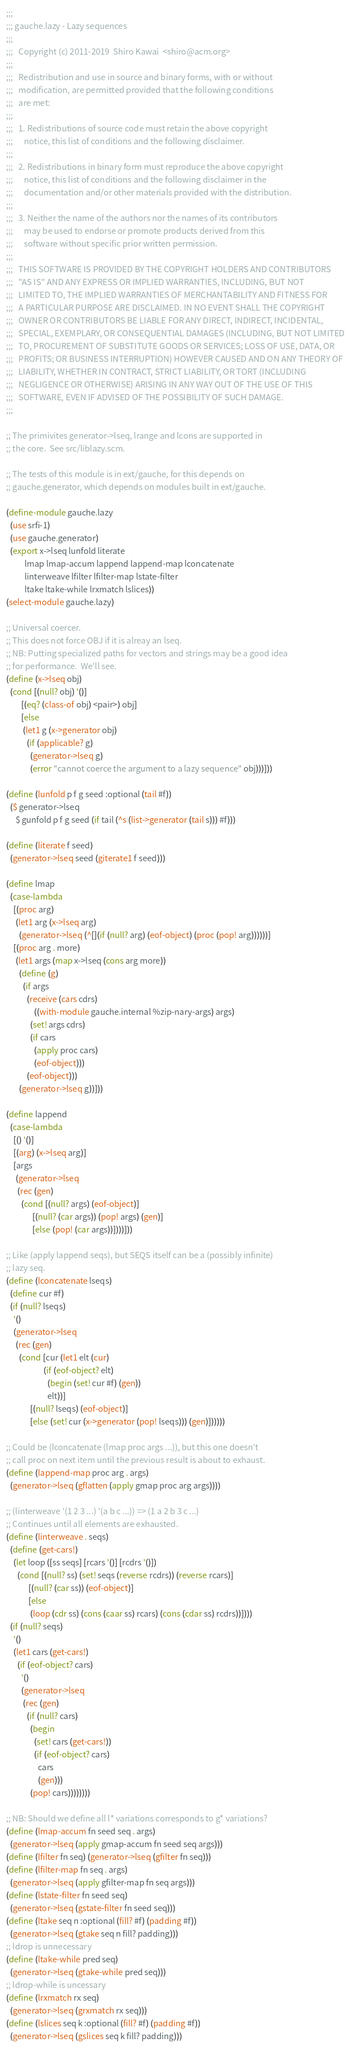<code> <loc_0><loc_0><loc_500><loc_500><_Scheme_>;;;
;;; gauche.lazy - Lazy sequences
;;;
;;;   Copyright (c) 2011-2019  Shiro Kawai  <shiro@acm.org>
;;;
;;;   Redistribution and use in source and binary forms, with or without
;;;   modification, are permitted provided that the following conditions
;;;   are met:
;;;
;;;   1. Redistributions of source code must retain the above copyright
;;;      notice, this list of conditions and the following disclaimer.
;;;
;;;   2. Redistributions in binary form must reproduce the above copyright
;;;      notice, this list of conditions and the following disclaimer in the
;;;      documentation and/or other materials provided with the distribution.
;;;
;;;   3. Neither the name of the authors nor the names of its contributors
;;;      may be used to endorse or promote products derived from this
;;;      software without specific prior written permission.
;;;
;;;   THIS SOFTWARE IS PROVIDED BY THE COPYRIGHT HOLDERS AND CONTRIBUTORS
;;;   "AS IS" AND ANY EXPRESS OR IMPLIED WARRANTIES, INCLUDING, BUT NOT
;;;   LIMITED TO, THE IMPLIED WARRANTIES OF MERCHANTABILITY AND FITNESS FOR
;;;   A PARTICULAR PURPOSE ARE DISCLAIMED. IN NO EVENT SHALL THE COPYRIGHT
;;;   OWNER OR CONTRIBUTORS BE LIABLE FOR ANY DIRECT, INDIRECT, INCIDENTAL,
;;;   SPECIAL, EXEMPLARY, OR CONSEQUENTIAL DAMAGES (INCLUDING, BUT NOT LIMITED
;;;   TO, PROCUREMENT OF SUBSTITUTE GOODS OR SERVICES; LOSS OF USE, DATA, OR
;;;   PROFITS; OR BUSINESS INTERRUPTION) HOWEVER CAUSED AND ON ANY THEORY OF
;;;   LIABILITY, WHETHER IN CONTRACT, STRICT LIABILITY, OR TORT (INCLUDING
;;;   NEGLIGENCE OR OTHERWISE) ARISING IN ANY WAY OUT OF THE USE OF THIS
;;;   SOFTWARE, EVEN IF ADVISED OF THE POSSIBILITY OF SUCH DAMAGE.
;;;

;; The primivites generator->lseq, lrange and lcons are supported in
;; the core.  See src/liblazy.scm.

;; The tests of this module is in ext/gauche, for this depends on
;; gauche.generator, which depends on modules built in ext/gauche.

(define-module gauche.lazy
  (use srfi-1)
  (use gauche.generator)
  (export x->lseq lunfold literate
          lmap lmap-accum lappend lappend-map lconcatenate
          linterweave lfilter lfilter-map lstate-filter
          ltake ltake-while lrxmatch lslices))
(select-module gauche.lazy)

;; Universal coercer.
;; This does not force OBJ if it is alreay an lseq.
;; NB: Putting specialized paths for vectors and strings may be a good idea
;; for performance.  We'll see.
(define (x->lseq obj)
  (cond [(null? obj) '()]
        [(eq? (class-of obj) <pair>) obj]
        [else
         (let1 g (x->generator obj)
           (if (applicable? g)
             (generator->lseq g)
             (error "cannot coerce the argument to a lazy sequence" obj)))]))

(define (lunfold p f g seed :optional (tail #f))
  ($ generator->lseq
     $ gunfold p f g seed (if tail (^s (list->generator (tail s))) #f)))

(define (literate f seed)
  (generator->lseq seed (giterate1 f seed)))

(define lmap
  (case-lambda
    [(proc arg)
     (let1 arg (x->lseq arg)
       (generator->lseq (^[](if (null? arg) (eof-object) (proc (pop! arg))))))]
    [(proc arg . more)
     (let1 args (map x->lseq (cons arg more))
       (define (g)
         (if args
           (receive (cars cdrs)
               ((with-module gauche.internal %zip-nary-args) args)
             (set! args cdrs)
             (if cars
               (apply proc cars)
               (eof-object)))
           (eof-object)))
       (generator->lseq g))]))

(define lappend
  (case-lambda
    [() '()]
    [(arg) (x->lseq arg)]
    [args
     (generator->lseq
      (rec (gen)
        (cond [(null? args) (eof-object)]
              [(null? (car args)) (pop! args) (gen)]
              [else (pop! (car args))])))]))

;; Like (apply lappend seqs), but SEQS itself can be a (possibly infinite)
;; lazy seq.
(define (lconcatenate lseqs)
  (define cur #f)
  (if (null? lseqs)
    '()
    (generator->lseq
     (rec (gen)
       (cond [cur (let1 elt (cur)
                    (if (eof-object? elt)
                      (begin (set! cur #f) (gen))
                      elt))]
             [(null? lseqs) (eof-object)]
             [else (set! cur (x->generator (pop! lseqs))) (gen)])))))

;; Could be (lconcatenate (lmap proc args ...)), but this one doesn't
;; call proc on next item until the previous result is about to exhaust.
(define (lappend-map proc arg . args)
  (generator->lseq (gflatten (apply gmap proc arg args))))

;; (linterweave '(1 2 3 ...) '(a b c ...)) => (1 a 2 b 3 c ...)
;; Continues until all elements are exhausted.
(define (linterweave . seqs)
  (define (get-cars!)
    (let loop ([ss seqs] [rcars '()] [rcdrs '()])
      (cond [(null? ss) (set! seqs (reverse rcdrs)) (reverse rcars)]
            [(null? (car ss)) (eof-object)]
            [else
             (loop (cdr ss) (cons (caar ss) rcars) (cons (cdar ss) rcdrs))])))
  (if (null? seqs)
    '()
    (let1 cars (get-cars!)
      (if (eof-object? cars)
        '()
        (generator->lseq
         (rec (gen)
           (if (null? cars)
             (begin
               (set! cars (get-cars!))
               (if (eof-object? cars)
                 cars
                 (gen)))
             (pop! cars))))))))

;; NB: Should we define all l* variations corresponds to g* variations?
(define (lmap-accum fn seed seq . args)
  (generator->lseq (apply gmap-accum fn seed seq args)))
(define (lfilter fn seq) (generator->lseq (gfilter fn seq)))
(define (lfilter-map fn seq . args)
  (generator->lseq (apply gfilter-map fn seq args)))
(define (lstate-filter fn seed seq)
  (generator->lseq (gstate-filter fn seed seq)))
(define (ltake seq n :optional (fill? #f) (padding #f))
  (generator->lseq (gtake seq n fill? padding)))
;; ldrop is unnecessary
(define (ltake-while pred seq)
  (generator->lseq (gtake-while pred seq)))
;; ldrop-while is uncessary
(define (lrxmatch rx seq)
  (generator->lseq (grxmatch rx seq)))
(define (lslices seq k :optional (fill? #f) (padding #f))
  (generator->lseq (gslices seq k fill? padding)))
</code> 